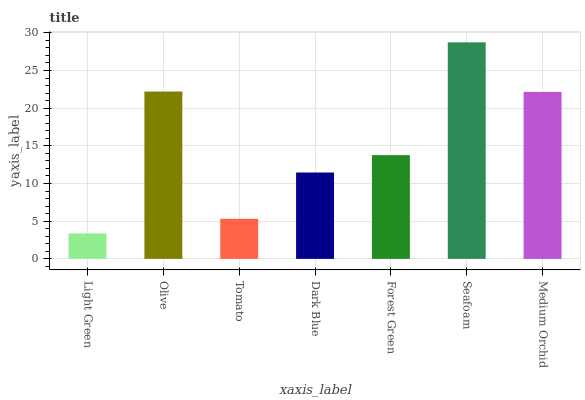Is Light Green the minimum?
Answer yes or no. Yes. Is Seafoam the maximum?
Answer yes or no. Yes. Is Olive the minimum?
Answer yes or no. No. Is Olive the maximum?
Answer yes or no. No. Is Olive greater than Light Green?
Answer yes or no. Yes. Is Light Green less than Olive?
Answer yes or no. Yes. Is Light Green greater than Olive?
Answer yes or no. No. Is Olive less than Light Green?
Answer yes or no. No. Is Forest Green the high median?
Answer yes or no. Yes. Is Forest Green the low median?
Answer yes or no. Yes. Is Tomato the high median?
Answer yes or no. No. Is Medium Orchid the low median?
Answer yes or no. No. 